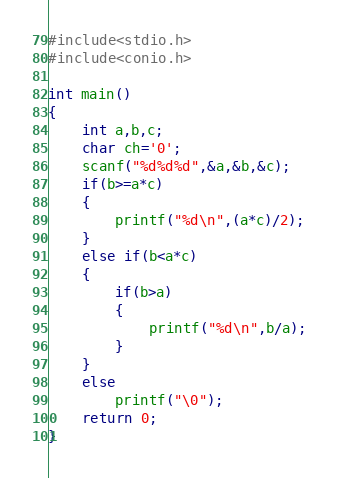Convert code to text. <code><loc_0><loc_0><loc_500><loc_500><_C_>#include<stdio.h>
#include<conio.h>

int main()
{
    int a,b,c;
    char ch='0';
    scanf("%d%d%d",&a,&b,&c);
    if(b>=a*c)
    {
        printf("%d\n",(a*c)/2);
    }
    else if(b<a*c)
    {
        if(b>a)
        {
            printf("%d\n",b/a);
        }
    }
    else
        printf("\0");
    return 0;
}
</code> 